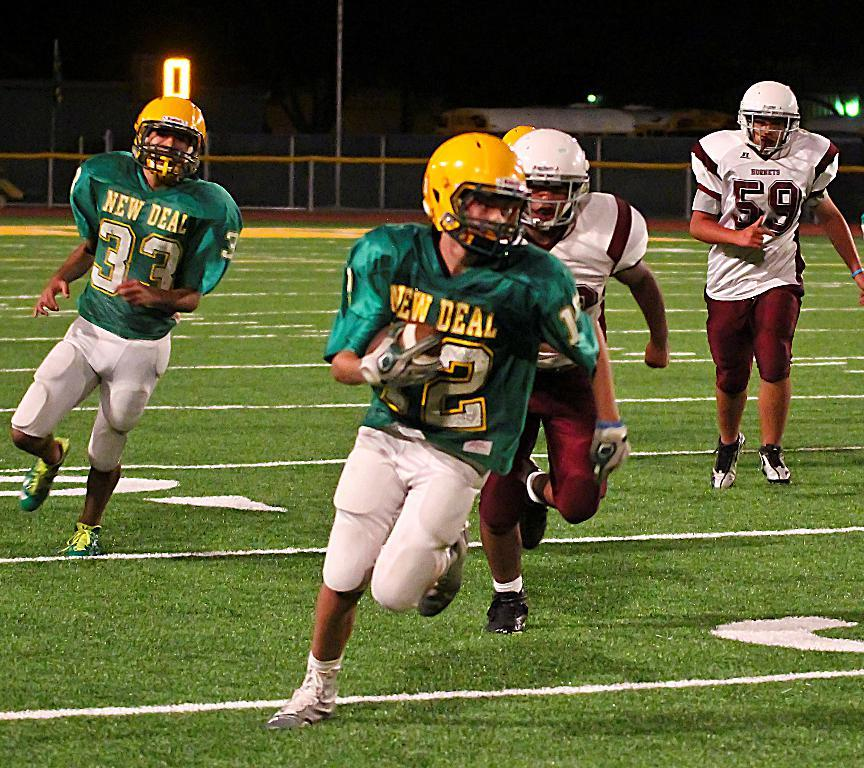What are the people in the image doing? The people in the image are playing. What type of clothing are the people wearing? The people are wearing sports dress. What protective gear are the people wearing? The people are wearing helmets. What type of footwear are the people wearing? The people are wearing shoes. What can be seen in the background of the image? There is a ground, railing, lights, and a pole visible in the background of the image. What type of birds can be seen flying under the bridge in the image? There are no birds or bridge present in the image. What type of underwear is visible on the people in the image? The image does not show the underwear of the people; it only shows their sports dress and helmets. 